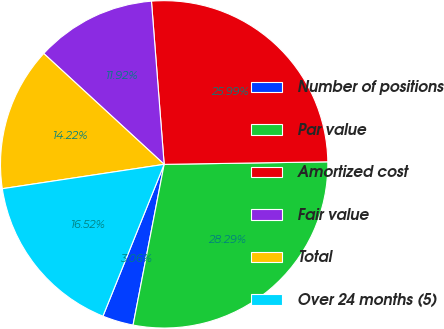<chart> <loc_0><loc_0><loc_500><loc_500><pie_chart><fcel>Number of positions<fcel>Par value<fcel>Amortized cost<fcel>Fair value<fcel>Total<fcel>Over 24 months (5)<nl><fcel>3.06%<fcel>28.29%<fcel>25.99%<fcel>11.92%<fcel>14.22%<fcel>16.52%<nl></chart> 